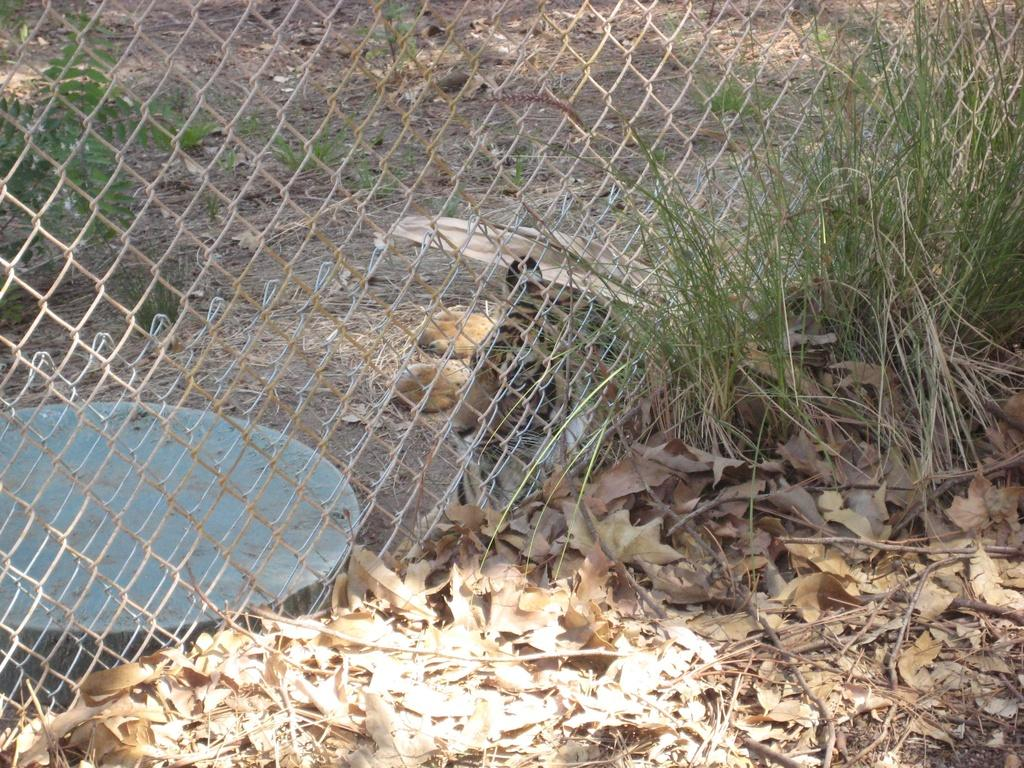What type of vegetation is at the bottom of the image? There is grass at the bottom of the image. What can be seen in the center of the image? There is a mesh in the center of the image. Where is the tray located in the image? The tray is on the left side of the image. What type of verse can be heard recited in the image? There is no indication of any verse or recitation in the image; it primarily features grass, a mesh, and a tray. What hall is visible in the image? There is no hall present in the image. 